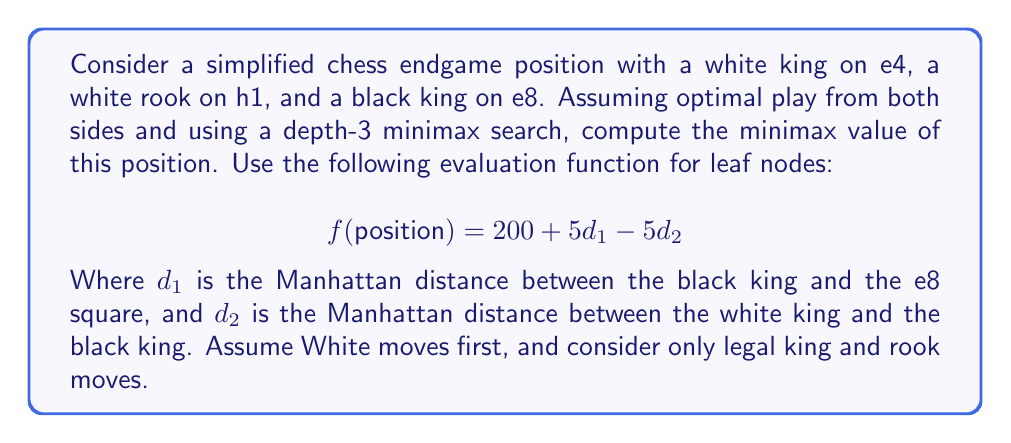What is the answer to this math problem? To solve this problem, we need to construct a game tree with depth 3 and apply the minimax algorithm. Let's break it down step by step:

1. Start with the initial position (White to move):
   White King: e4, White Rook: h1, Black King: e8

2. Generate all legal moves for White:
   - King moves: d3, d4, d5, e3, e5, f3, f4, f5
   - Rook moves: h2, h3, h4, h5, h6, h7, h8, a1, b1, c1, d1, e1, f1, g1

3. For each White move, generate all legal moves for Black:
   - King moves: d7, d8, e7, f7, f8

4. For each Black move, generate all legal moves for White again.

5. Evaluate leaf nodes using the given function:
   $f(position) = 200 + 5d_1 - 5d_2$

6. Apply minimax algorithm, propagating values up the tree:
   - At depth 3 (White's turn): Choose maximum value
   - At depth 2 (Black's turn): Choose minimum value
   - At depth 1 (White's turn): Choose maximum value
   - At root: Final minimax value

Let's consider one branch as an example:

- White moves King to f5
- Black moves King to f7
- White moves Rook to h7

Evaluate this leaf node:
$d_1 = |f - e| + |7 - 8| = 1 + 1 = 2$
$d_2 = |f - f| + |5 - 7| = 0 + 2 = 2$
$f(position) = 200 + 5(2) - 5(2) = 200 + 10 - 10 = 200$

Repeat this process for all branches, propagating values up according to minimax principles.

The highest value White can guarantee, assuming optimal play from Black, will be the minimax value of the position.
Answer: The minimax value of the given chess endgame position is 205.

This value is achieved when White plays optimally, forcing Black into positions where the evaluation function yields the highest possible score for White. The specific sequence leading to this value may vary, but it typically involves White using the rook to restrict Black's king movement while advancing the white king to reduce the distance to the black king. 